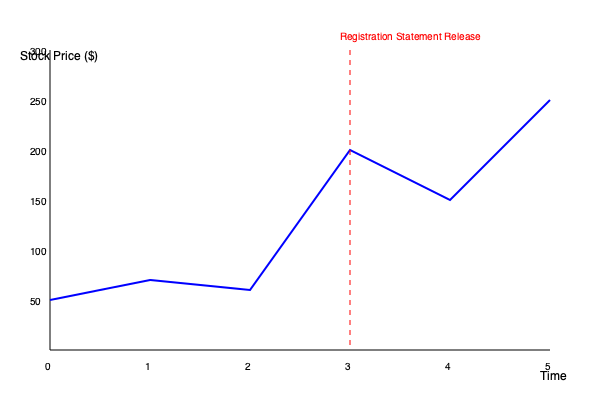Based on the line graph showing stock price fluctuations before and after the registration statement release, what is the most significant trend observed in the stock price following the release, and how might this impact your strategy as a litigator representing a shareholder challenging the accuracy of the registration statement? To analyze the graph and determine the strategy:

1. Identify the registration statement release point:
   - The red dashed line at time point 3 represents the release.

2. Observe pre-release trend:
   - Stock price fluctuates between $50 and $100 from time 0 to 3.
   - Relatively stable with minor variations.

3. Analyze post-release trend:
   - Sharp increase from $150 to $250 between time 3 and 5.
   - Represents a significant upward trend after the release.

4. Calculate the rate of change:
   - Pre-release: Approximately $0 to $50 increase over 3 time units.
   - Post-release: Approximately $100 increase over 2 time units.
   - Post-release rate of change is significantly higher.

5. Interpret the impact:
   - Rapid price increase suggests positive market reaction.
   - This could indicate that the registration statement contained favorable information.

6. Consider litigation strategy:
   - Challenge the accuracy if the statement overstated positives or understated risks.
   - Focus on any discrepancies between the statement and actual company performance.
   - Investigate if there was any undisclosed information that could explain the sharp rise.
   - Examine if the price increase was artificially inflated due to misrepresentation.

7. Key areas to investigate:
   - Financial projections in the statement vs. actual performance.
   - Risk disclosures and their adequacy.
   - Any material information omitted from the statement.
   - Timing of the release in relation to other company announcements or market events.

As a litigator, the strategy would involve scrutinizing the registration statement's content against the dramatic stock price increase, seeking any inaccuracies or omissions that could have contributed to this market reaction.
Answer: Sharp upward trend post-release; investigate potential misrepresentation or omission of material information in registration statement causing artificial price inflation. 